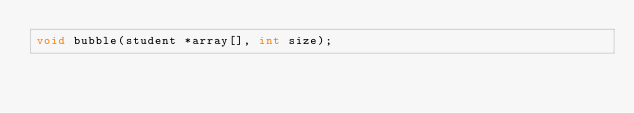Convert code to text. <code><loc_0><loc_0><loc_500><loc_500><_C_>void bubble(student *array[], int size);
</code> 